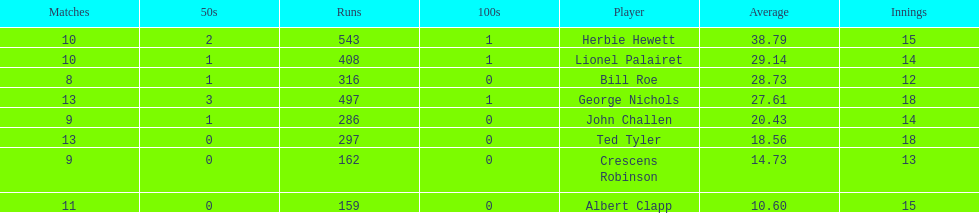In how many innings did albert clapp participate? 15. 